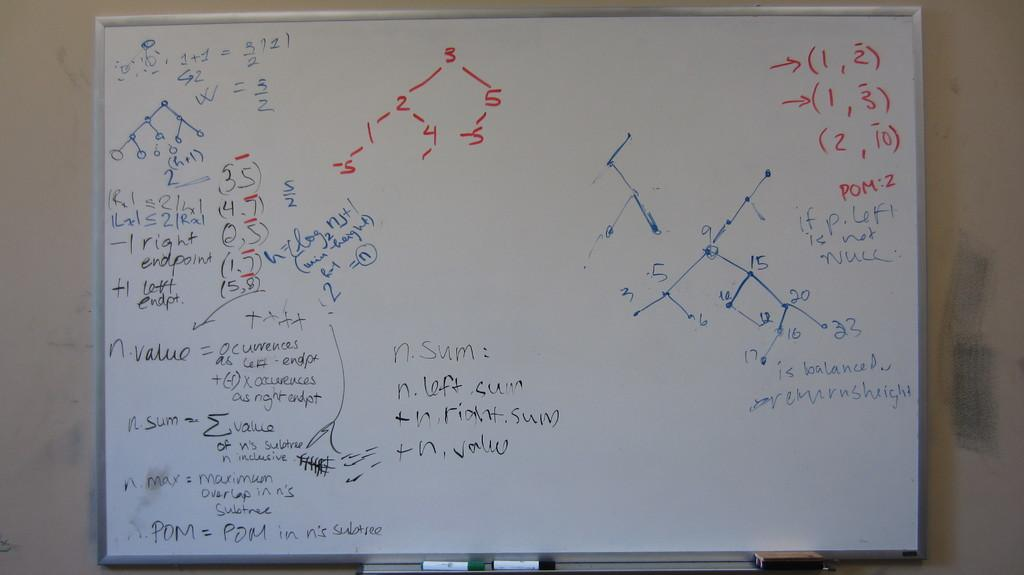<image>
Give a short and clear explanation of the subsequent image. Red writing on the white board says 1,2, and 1,3. 